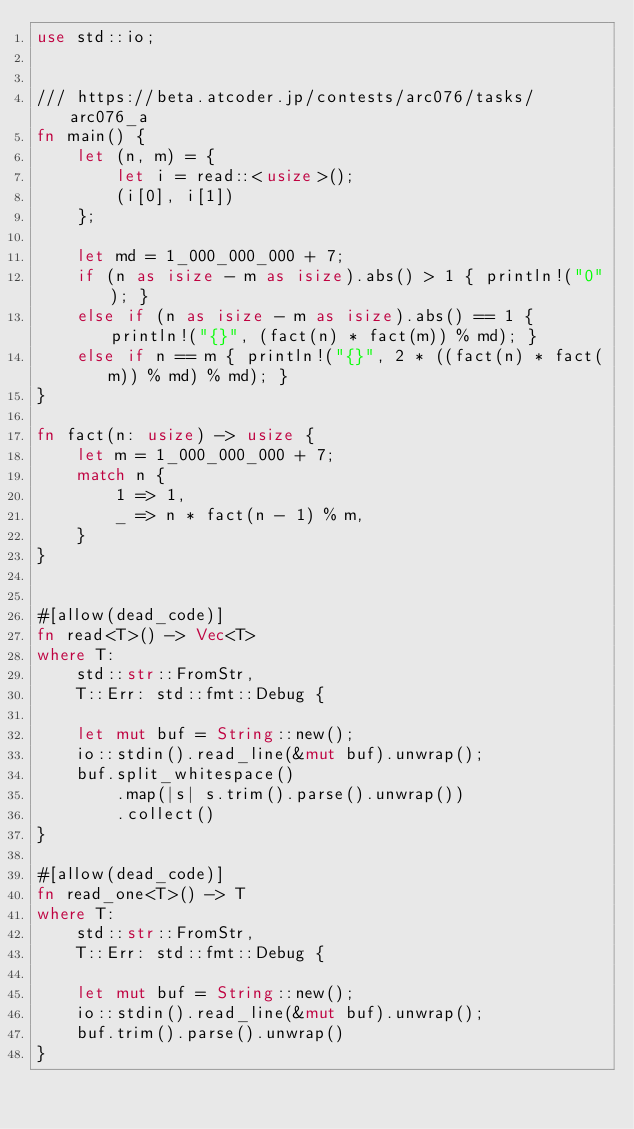<code> <loc_0><loc_0><loc_500><loc_500><_Rust_>use std::io;


/// https://beta.atcoder.jp/contests/arc076/tasks/arc076_a
fn main() {
    let (n, m) = {
        let i = read::<usize>();
        (i[0], i[1])
    };

    let md = 1_000_000_000 + 7;
    if (n as isize - m as isize).abs() > 1 { println!("0"); }
    else if (n as isize - m as isize).abs() == 1 { println!("{}", (fact(n) * fact(m)) % md); }
    else if n == m { println!("{}", 2 * ((fact(n) * fact(m)) % md) % md); }
}
 
fn fact(n: usize) -> usize {
    let m = 1_000_000_000 + 7;
    match n {
        1 => 1,
        _ => n * fact(n - 1) % m,
    }
}


#[allow(dead_code)]
fn read<T>() -> Vec<T>
where T:
    std::str::FromStr,
    T::Err: std::fmt::Debug {

    let mut buf = String::new();
    io::stdin().read_line(&mut buf).unwrap();
    buf.split_whitespace()
        .map(|s| s.trim().parse().unwrap())
        .collect()
}

#[allow(dead_code)]
fn read_one<T>() -> T
where T:
    std::str::FromStr,
    T::Err: std::fmt::Debug {

    let mut buf = String::new();
    io::stdin().read_line(&mut buf).unwrap();
    buf.trim().parse().unwrap()
}</code> 